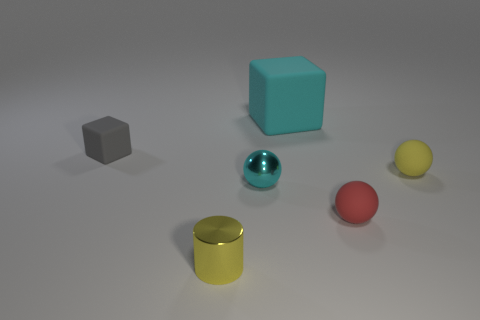Subtract all small metallic balls. How many balls are left? 2 Add 3 red rubber cubes. How many objects exist? 9 Subtract 1 balls. How many balls are left? 2 Subtract all cyan spheres. How many spheres are left? 2 Subtract 0 purple cylinders. How many objects are left? 6 Subtract all cylinders. How many objects are left? 5 Subtract all red cubes. Subtract all brown balls. How many cubes are left? 2 Subtract all big matte blocks. Subtract all tiny cyan spheres. How many objects are left? 4 Add 5 small yellow matte spheres. How many small yellow matte spheres are left? 6 Add 3 small yellow metallic objects. How many small yellow metallic objects exist? 4 